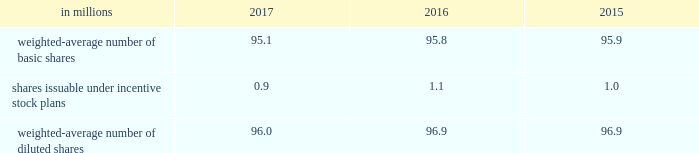Note 18 2013 earnings per share ( eps ) basic eps is calculated by dividing net earnings attributable to allegion plc by the weighted-average number of ordinary shares outstanding for the applicable period .
Diluted eps is calculated after adjusting the denominator of the basic eps calculation for the effect of all potentially dilutive ordinary shares , which in the company 2019s case , includes shares issuable under share-based compensation plans .
The table summarizes the weighted-average number of ordinary shares outstanding for basic and diluted earnings per share calculations. .
At december 31 , 2017 , 0.1 million stock options were excluded from the computation of weighted average diluted shares outstanding because the effect of including these shares would have been anti-dilutive .
Note 19 2013 commitments and contingencies the company is involved in various litigations , claims and administrative proceedings , including those related to environmental and product warranty matters .
Amounts recorded for identified contingent liabilities are estimates , which are reviewed periodically and adjusted to reflect additional information when it becomes available .
Subject to the uncertainties inherent in estimating future costs for contingent liabilities , except as expressly set forth in this note , management believes that any liability which may result from these legal matters would not have a material adverse effect on the financial condition , results of operations , liquidity or cash flows of the company .
Environmental matters the company is dedicated to an environmental program to reduce the utilization and generation of hazardous materials during the manufacturing process and to remediate identified environmental concerns .
As to the latter , the company is currently engaged in site investigations and remediation activities to address environmental cleanup from past operations at current and former production facilities .
The company regularly evaluates its remediation programs and considers alternative remediation methods that are in addition to , or in replacement of , those currently utilized by the company based upon enhanced technology and regulatory changes .
Changes to the company's remediation programs may result in increased expenses and increased environmental reserves .
The company is sometimes a party to environmental lawsuits and claims and has received notices of potential violations of environmental laws and regulations from the u.s .
Environmental protection agency and similar state authorities .
It has also been identified as a potentially responsible party ( "prp" ) for cleanup costs associated with off-site waste disposal at federal superfund and state remediation sites .
For all such sites , there are other prps and , in most instances , the company 2019s involvement is minimal .
In estimating its liability , the company has assumed it will not bear the entire cost of remediation of any site to the exclusion of other prps who may be jointly and severally liable .
The ability of other prps to participate has been taken into account , based on our understanding of the parties 2019 financial condition and probable contributions on a per site basis .
Additional lawsuits and claims involving environmental matters are likely to arise from time to time in the future .
The company incurred $ 3.2 million , $ 23.3 million , and $ 4.4 million of expenses during the years ended december 31 , 2017 , 2016 and 2015 , respectively , for environmental remediation at sites presently or formerly owned or leased by the company .
In the fourth-quarter of 2016 , with the collaboration and approval of state regulators , the company launched a proactive , alternative approach to remediate two sites in the united states .
This approach will allow the company to more aggressively address environmental conditions at these sites and reduce the impact of potential changes in regulatory requirements .
As a result , the company recorded a $ 15 million charge for environmental remediation in the fourth quarter of 2016 .
Environmental remediation costs are recorded in costs of goods sold within the consolidated statements of comprehensive income .
As of december 31 , 2017 and 2016 , the company has recorded reserves for environmental matters of $ 28.9 million and $ 30.6 million .
The total reserve at december 31 , 2017 and 2016 included $ 8.9 million and $ 9.6 million related to remediation of sites previously disposed by the company .
Environmental reserves are classified as accrued expenses and other current liabilities or other noncurrent liabilities based on their expected term .
The company's total current environmental reserve at december 31 , 2017 and 2016 was $ 12.6 million and $ 6.1 million and the remainder is classified as noncurrent .
Given the evolving nature of environmental laws , regulations and technology , the ultimate cost of future compliance is uncertain. .
Considering the years 2015-2017 , what is the average expense for environmental remediation at sites , in millions of dollars? 
Rationale: it is the sum of all environmental remediation expenses during these years , divided by three ( number of years ) .
Computations: ((4.4 + (3.2 + 23.3)) / 3)
Answer: 10.3. 